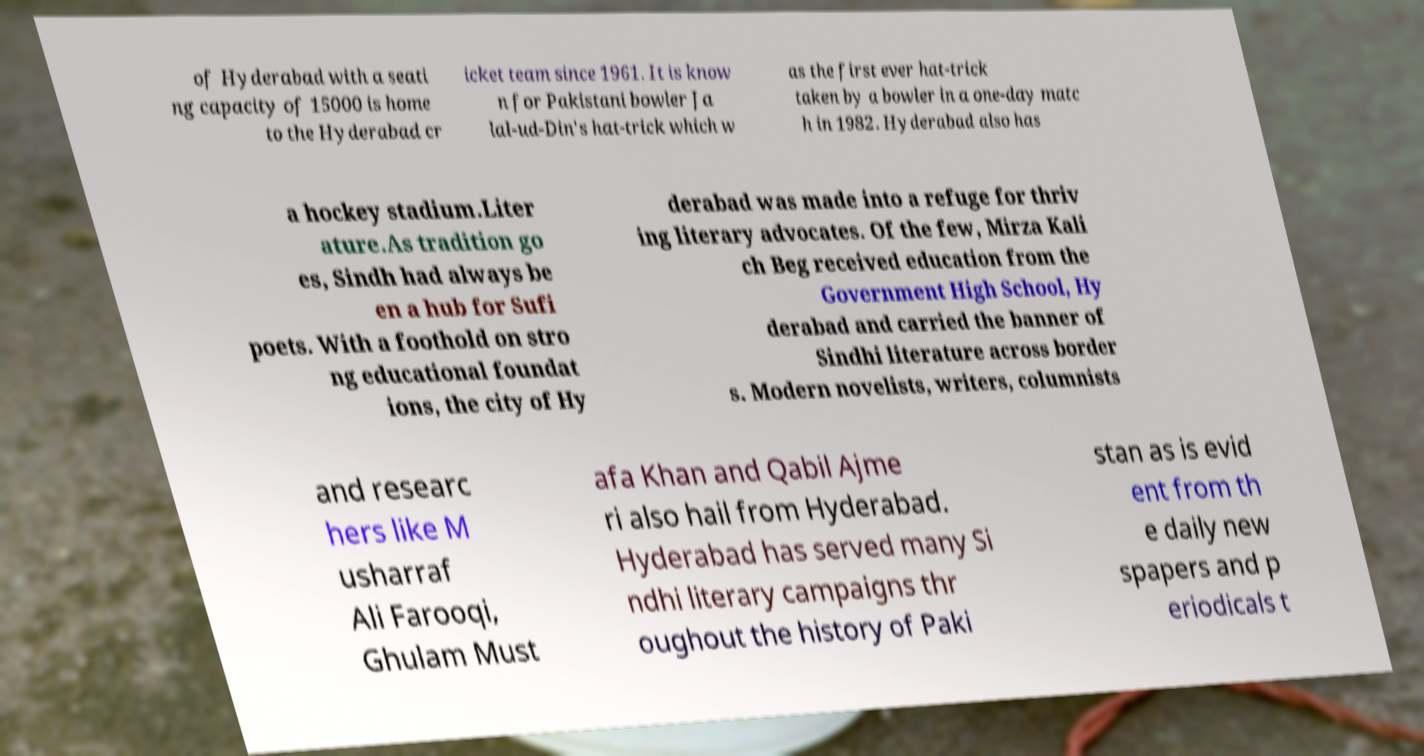Could you extract and type out the text from this image? of Hyderabad with a seati ng capacity of 15000 is home to the Hyderabad cr icket team since 1961. It is know n for Pakistani bowler Ja lal-ud-Din's hat-trick which w as the first ever hat-trick taken by a bowler in a one-day matc h in 1982. Hyderabad also has a hockey stadium.Liter ature.As tradition go es, Sindh had always be en a hub for Sufi poets. With a foothold on stro ng educational foundat ions, the city of Hy derabad was made into a refuge for thriv ing literary advocates. Of the few, Mirza Kali ch Beg received education from the Government High School, Hy derabad and carried the banner of Sindhi literature across border s. Modern novelists, writers, columnists and researc hers like M usharraf Ali Farooqi, Ghulam Must afa Khan and Qabil Ajme ri also hail from Hyderabad. Hyderabad has served many Si ndhi literary campaigns thr oughout the history of Paki stan as is evid ent from th e daily new spapers and p eriodicals t 